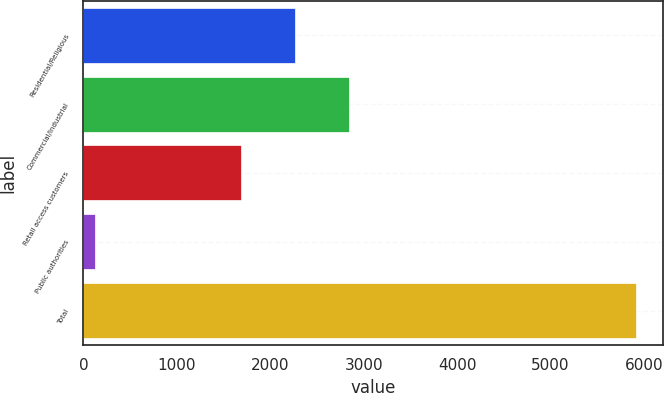Convert chart. <chart><loc_0><loc_0><loc_500><loc_500><bar_chart><fcel>Residential/Religious<fcel>Commercial/Industrial<fcel>Retail access customers<fcel>Public authorities<fcel>Total<nl><fcel>2266.1<fcel>2845.2<fcel>1687<fcel>120<fcel>5911<nl></chart> 